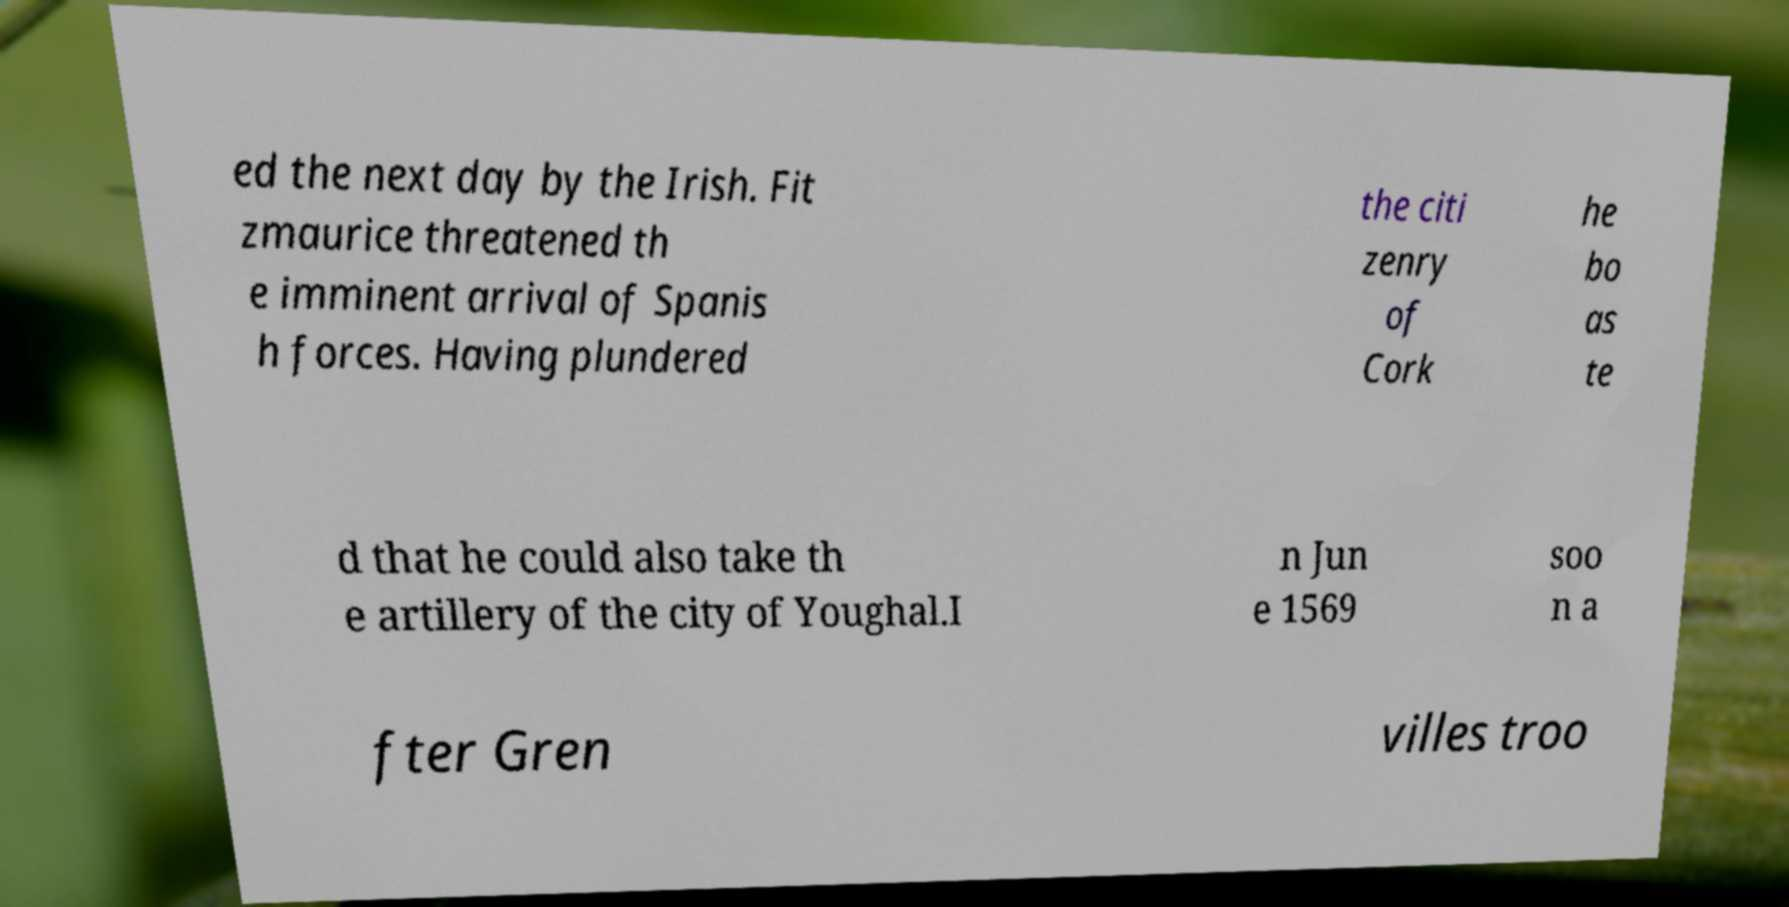Can you accurately transcribe the text from the provided image for me? ed the next day by the Irish. Fit zmaurice threatened th e imminent arrival of Spanis h forces. Having plundered the citi zenry of Cork he bo as te d that he could also take th e artillery of the city of Youghal.I n Jun e 1569 soo n a fter Gren villes troo 